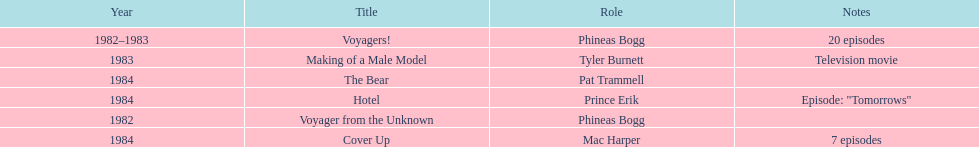Could you help me parse every detail presented in this table? {'header': ['Year', 'Title', 'Role', 'Notes'], 'rows': [['1982–1983', 'Voyagers!', 'Phineas Bogg', '20 episodes'], ['1983', 'Making of a Male Model', 'Tyler Burnett', 'Television movie'], ['1984', 'The Bear', 'Pat Trammell', ''], ['1984', 'Hotel', 'Prince Erik', 'Episode: "Tomorrows"'], ['1982', 'Voyager from the Unknown', 'Phineas Bogg', ''], ['1984', 'Cover Up', 'Mac Harper', '7 episodes']]} In what year did he portray mac harper and pat trammell? 1984. 